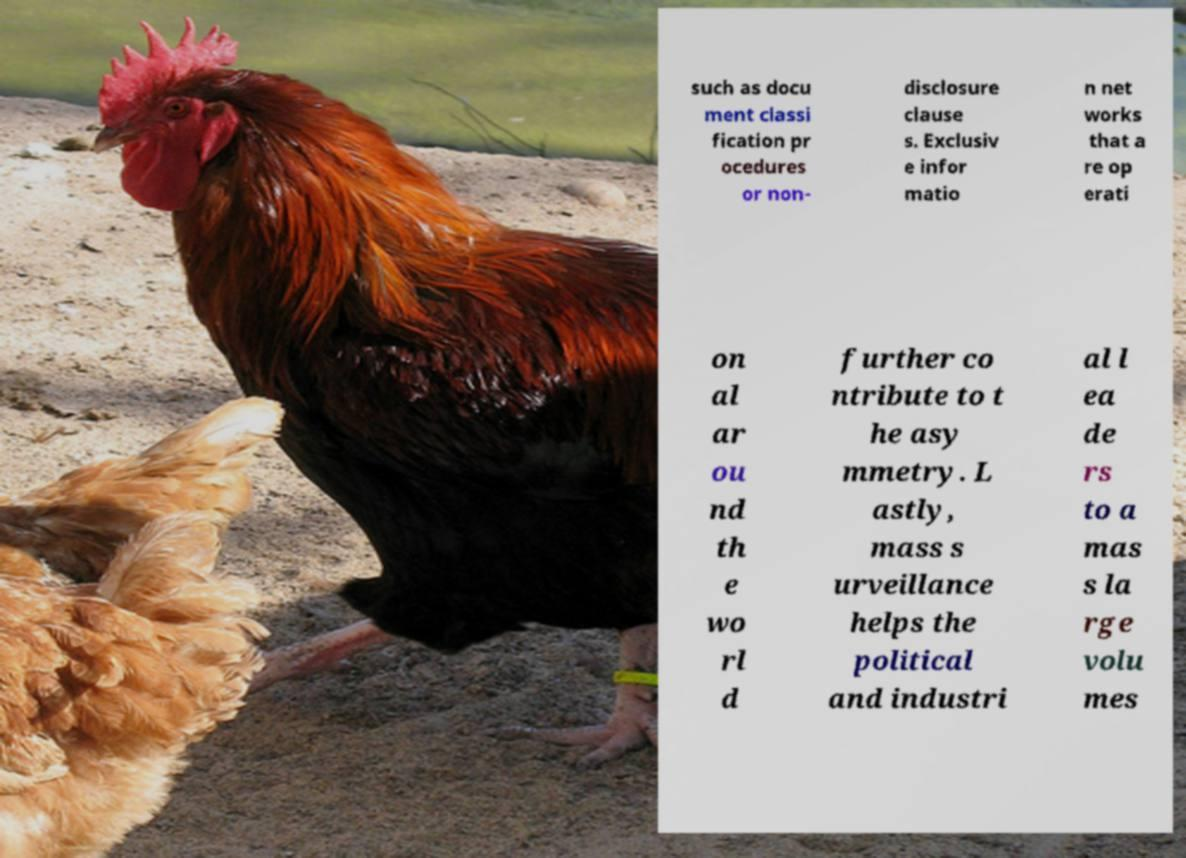Could you assist in decoding the text presented in this image and type it out clearly? such as docu ment classi fication pr ocedures or non- disclosure clause s. Exclusiv e infor matio n net works that a re op erati on al ar ou nd th e wo rl d further co ntribute to t he asy mmetry. L astly, mass s urveillance helps the political and industri al l ea de rs to a mas s la rge volu mes 